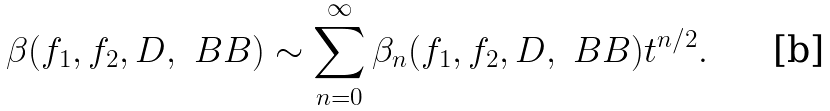Convert formula to latex. <formula><loc_0><loc_0><loc_500><loc_500>\beta ( f _ { 1 } , f _ { 2 } , D , \ B B ) \sim \sum _ { n = 0 } ^ { \infty } \beta _ { n } ( f _ { 1 } , f _ { 2 } , D , \ B B ) t ^ { n / 2 } .</formula> 